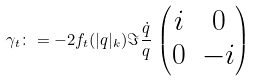Convert formula to latex. <formula><loc_0><loc_0><loc_500><loc_500>\gamma _ { t } \colon = - 2 f _ { t } ( | q | _ { k } ) \Im \frac { \dot { q } } { q } \, \begin{pmatrix} i & 0 \\ 0 & - i \end{pmatrix}</formula> 